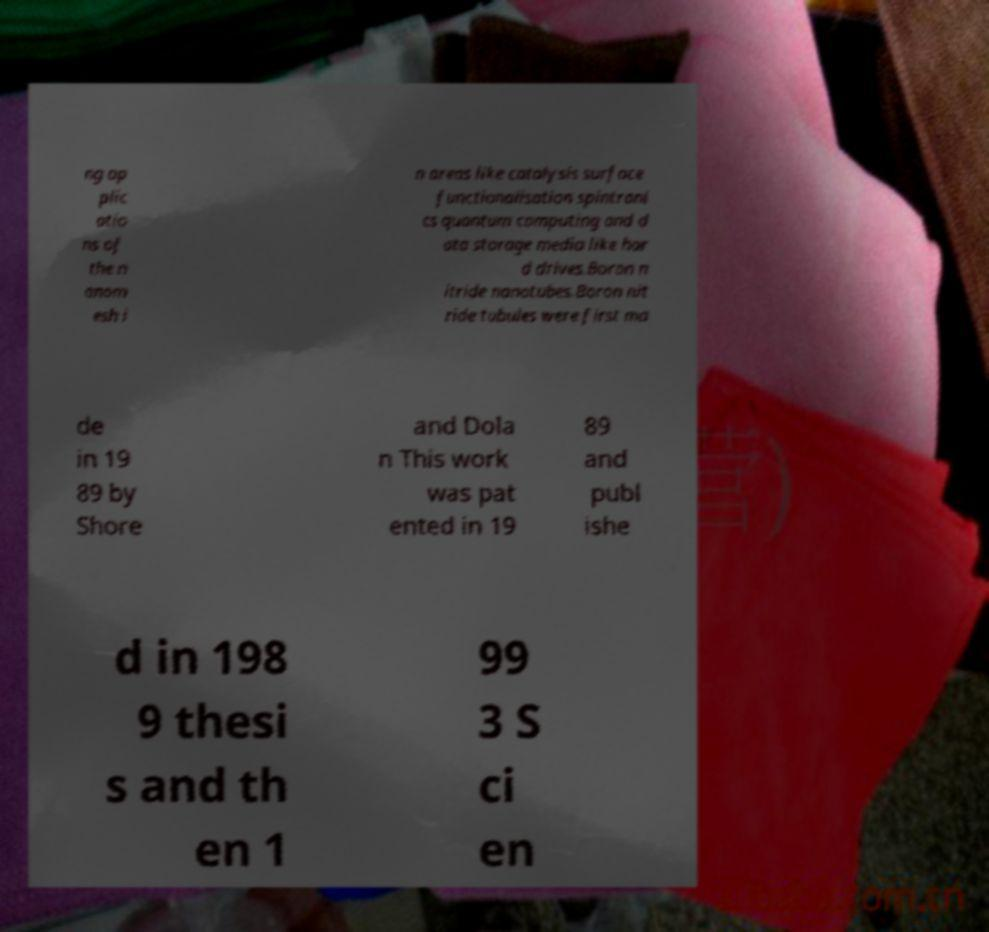I need the written content from this picture converted into text. Can you do that? ng ap plic atio ns of the n anom esh i n areas like catalysis surface functionalisation spintroni cs quantum computing and d ata storage media like har d drives.Boron n itride nanotubes.Boron nit ride tubules were first ma de in 19 89 by Shore and Dola n This work was pat ented in 19 89 and publ ishe d in 198 9 thesi s and th en 1 99 3 S ci en 